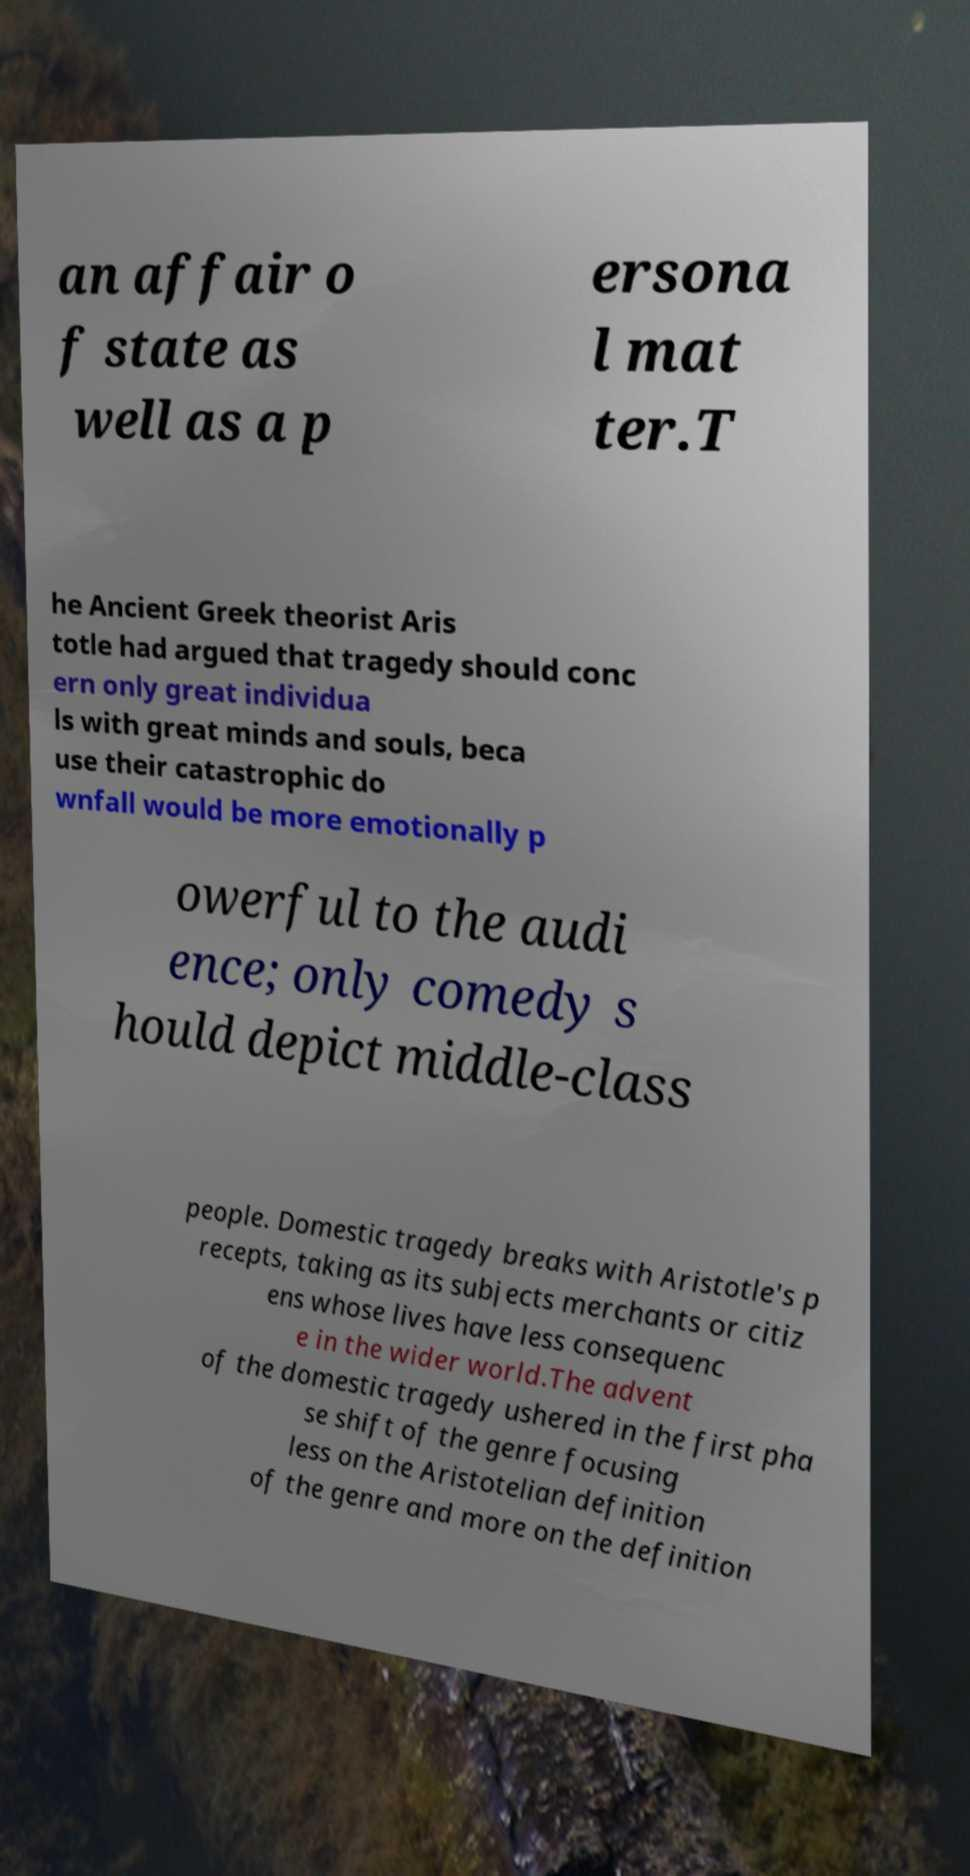There's text embedded in this image that I need extracted. Can you transcribe it verbatim? an affair o f state as well as a p ersona l mat ter.T he Ancient Greek theorist Aris totle had argued that tragedy should conc ern only great individua ls with great minds and souls, beca use their catastrophic do wnfall would be more emotionally p owerful to the audi ence; only comedy s hould depict middle-class people. Domestic tragedy breaks with Aristotle's p recepts, taking as its subjects merchants or citiz ens whose lives have less consequenc e in the wider world.The advent of the domestic tragedy ushered in the first pha se shift of the genre focusing less on the Aristotelian definition of the genre and more on the definition 